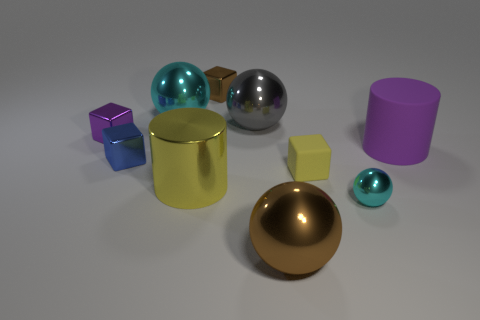Is the color of the large shiny cylinder the same as the tiny rubber cube?
Your answer should be very brief. Yes. What number of other objects are there of the same size as the yellow shiny thing?
Give a very brief answer. 4. Does the cyan object that is in front of the blue metallic object have the same shape as the gray shiny object?
Provide a succinct answer. Yes. There is a metallic object that is the same shape as the purple matte thing; what color is it?
Provide a succinct answer. Yellow. Is the number of big cyan balls in front of the metal cylinder the same as the number of green matte blocks?
Your response must be concise. Yes. How many large objects are both behind the tiny blue metallic cube and left of the big gray metallic sphere?
Offer a terse response. 1. What is the size of the other matte thing that is the same shape as the blue thing?
Offer a very short reply. Small. How many small yellow blocks have the same material as the tiny purple block?
Provide a short and direct response. 0. Is the number of tiny yellow objects that are left of the brown block less than the number of red objects?
Make the answer very short. No. What number of tiny yellow rubber cylinders are there?
Give a very brief answer. 0. 